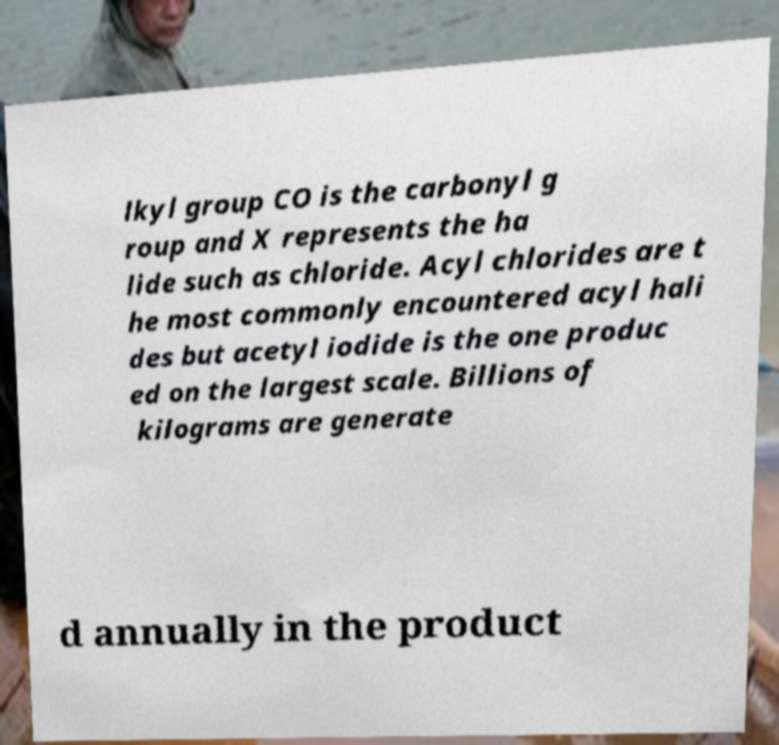I need the written content from this picture converted into text. Can you do that? lkyl group CO is the carbonyl g roup and X represents the ha lide such as chloride. Acyl chlorides are t he most commonly encountered acyl hali des but acetyl iodide is the one produc ed on the largest scale. Billions of kilograms are generate d annually in the product 